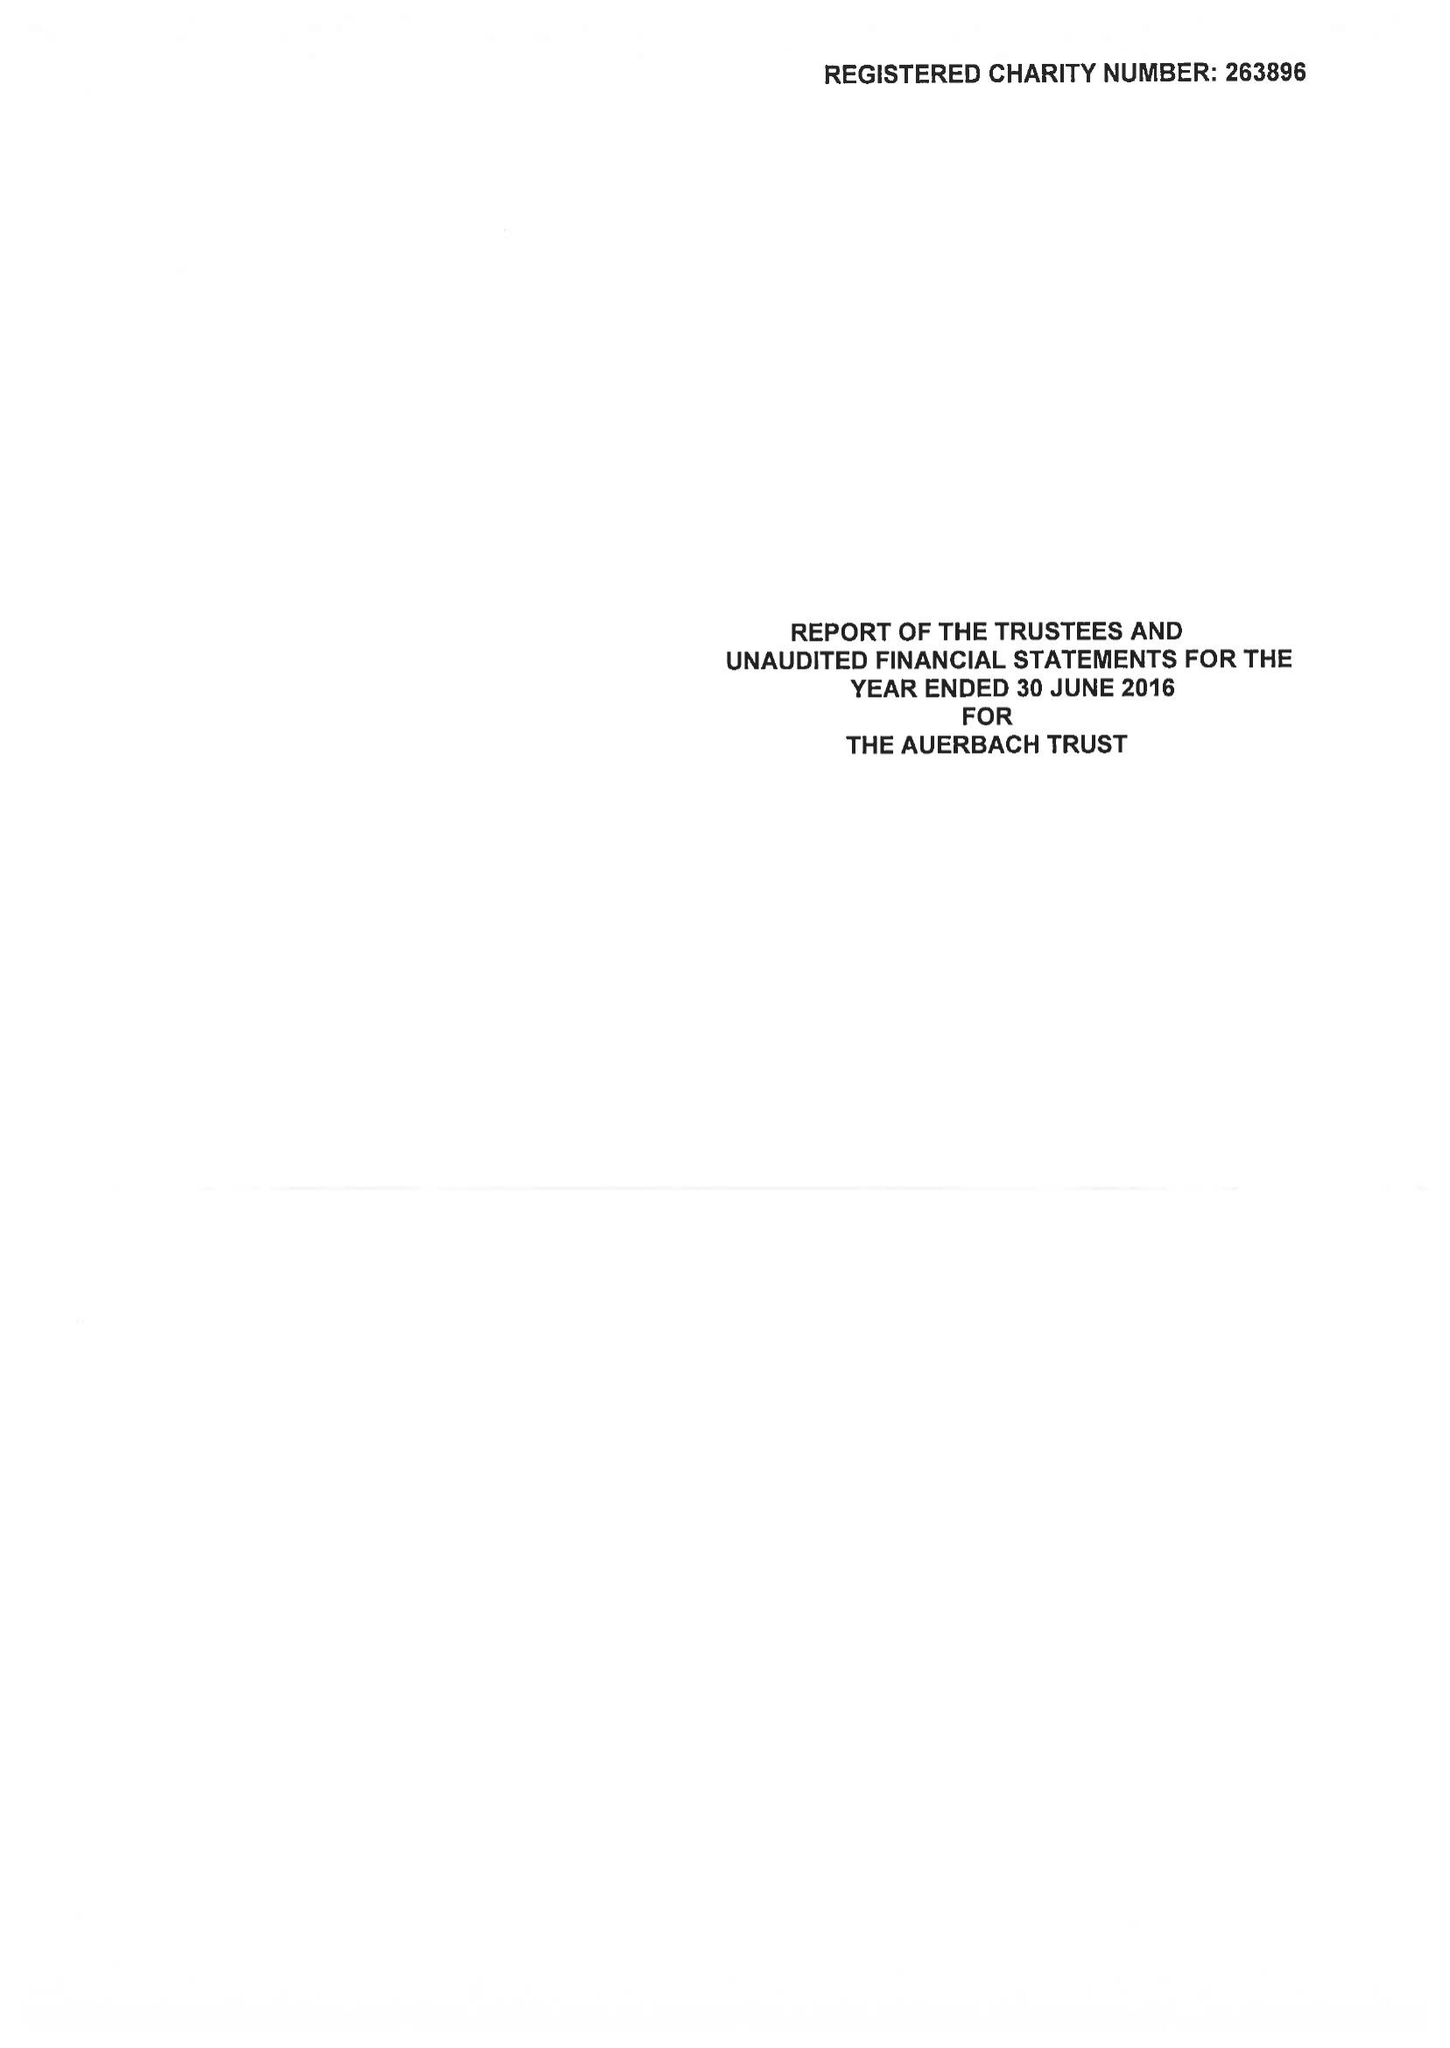What is the value for the address__postcode?
Answer the question using a single word or phrase. NW1 4RD 